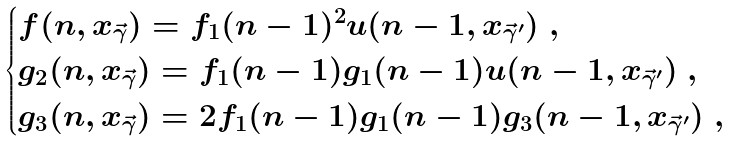<formula> <loc_0><loc_0><loc_500><loc_500>\begin{cases} f ( n , x _ { \vec { \gamma } } ) = f _ { 1 } ( n - 1 ) ^ { 2 } u ( n - 1 , x _ { \vec { \gamma } ^ { \prime } } ) \ , \\ g _ { 2 } ( n , x _ { \vec { \gamma } } ) = f _ { 1 } ( n - 1 ) g _ { 1 } ( n - 1 ) u ( n - 1 , x _ { \vec { \gamma } ^ { \prime } } ) \ , \\ g _ { 3 } ( n , x _ { \vec { \gamma } } ) = 2 f _ { 1 } ( n - 1 ) g _ { 1 } ( n - 1 ) g _ { 3 } ( n - 1 , x _ { \vec { \gamma } ^ { \prime } } ) \ , \end{cases}</formula> 